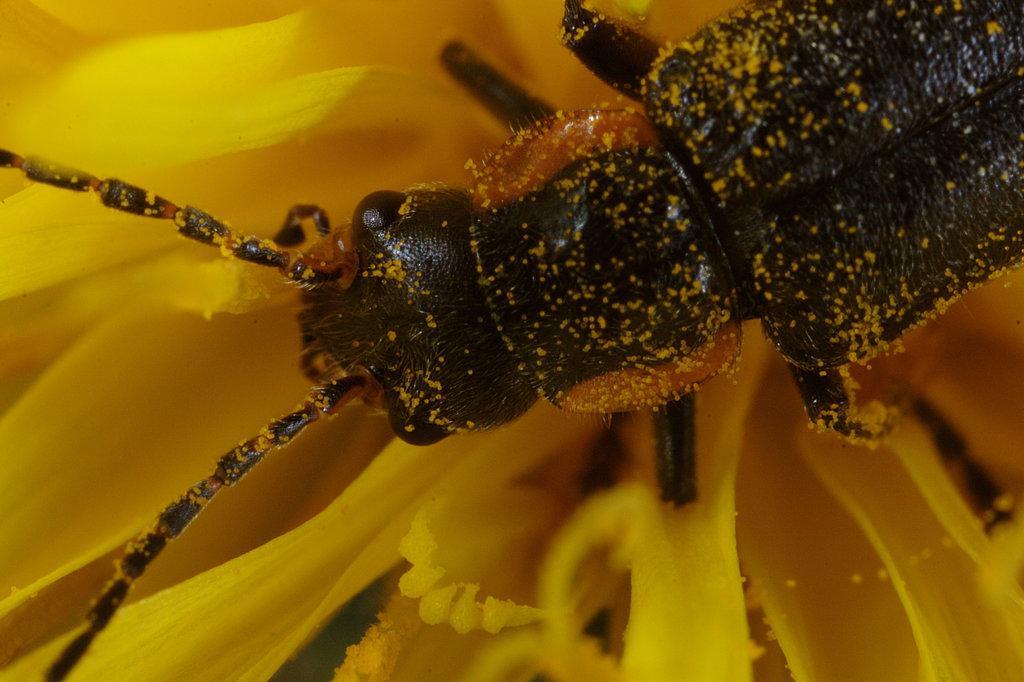Describe this image in one or two sentences. This is a bee on a flower. 